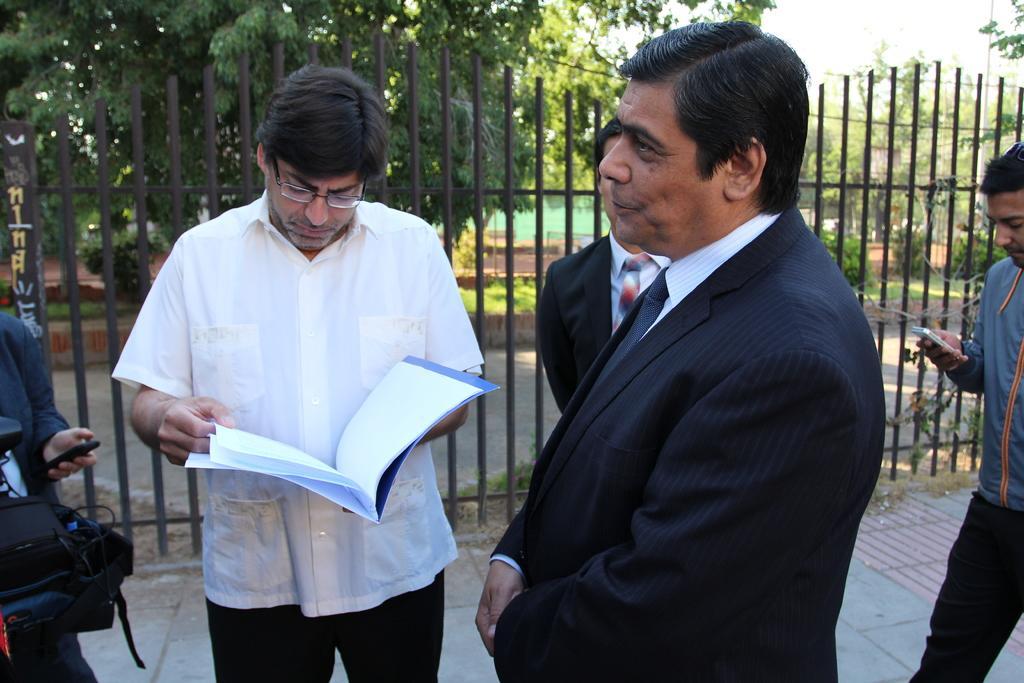How would you summarize this image in a sentence or two? In this picture there is a man holding a file in his hands. He is wearing spectacles. There are some people standing here beside him. In the background there is a railing and some trees here. We can observe a man walking in the right side holding a mobile phone. 